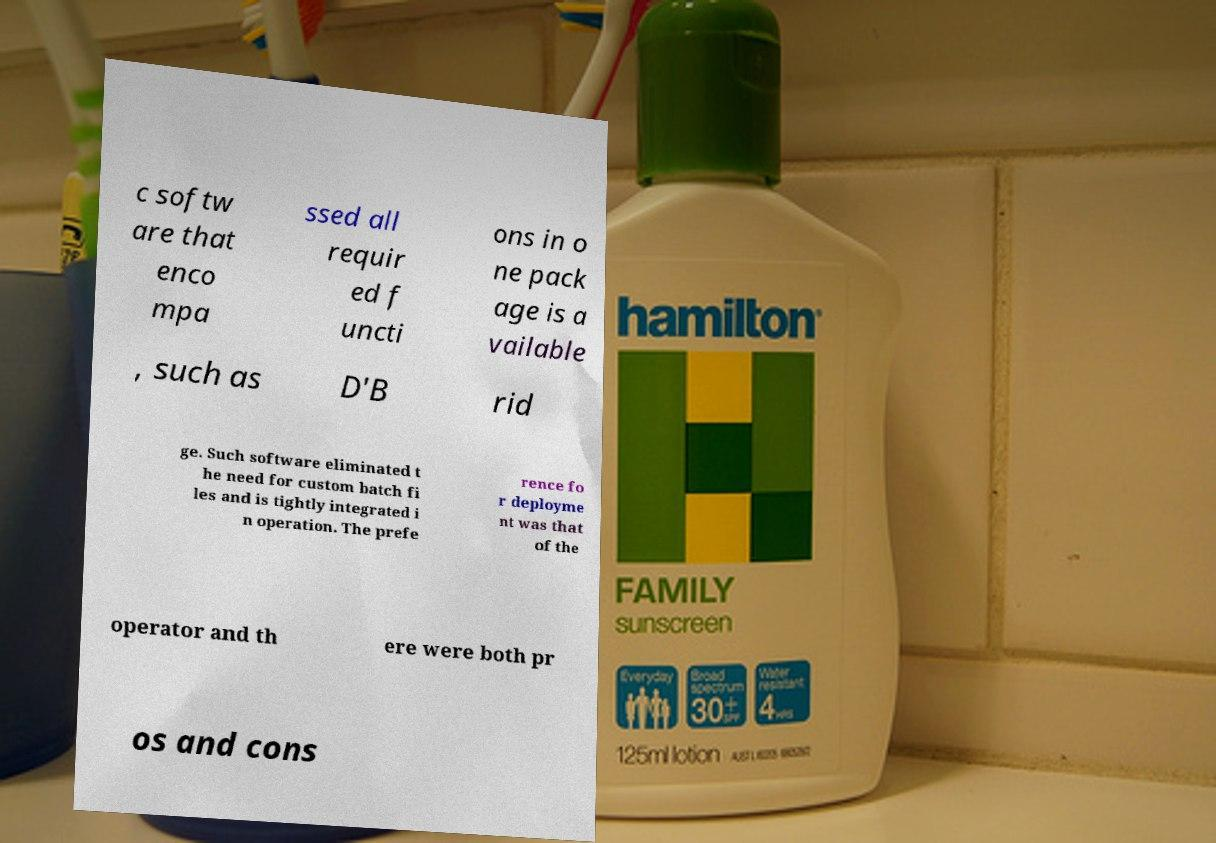Can you read and provide the text displayed in the image?This photo seems to have some interesting text. Can you extract and type it out for me? c softw are that enco mpa ssed all requir ed f uncti ons in o ne pack age is a vailable , such as D'B rid ge. Such software eliminated t he need for custom batch fi les and is tightly integrated i n operation. The prefe rence fo r deployme nt was that of the operator and th ere were both pr os and cons 